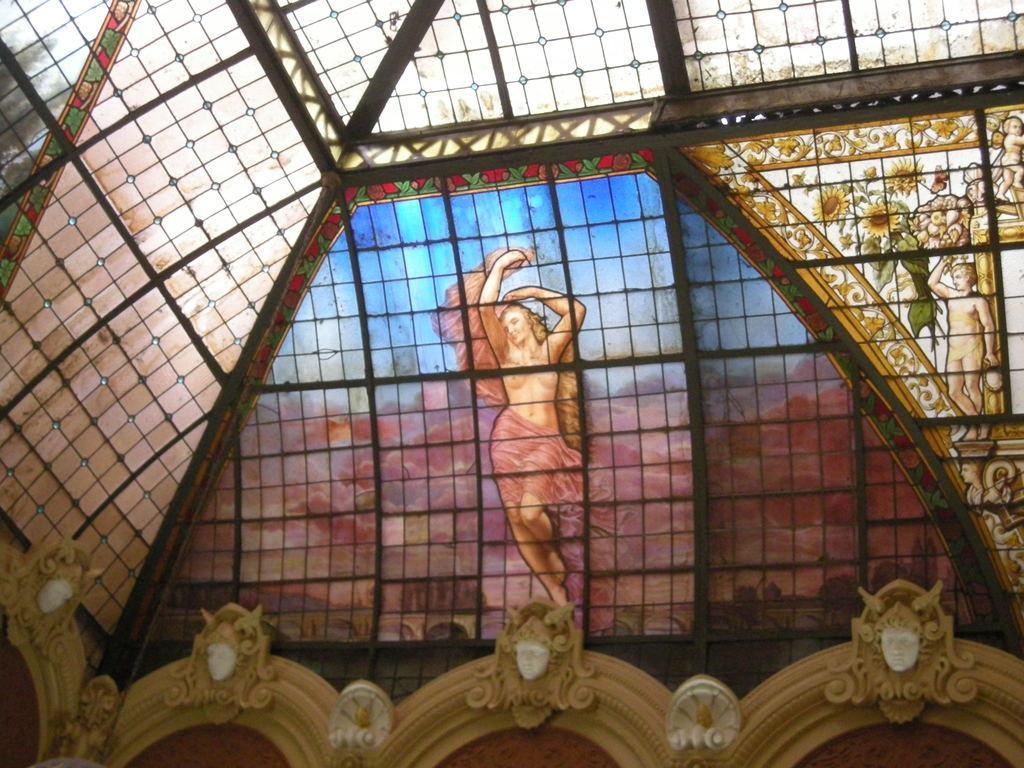In one or two sentences, can you explain what this image depicts? In this image we can see grills, design glass walls and statues. On this designed glass wall we can see flowers. 